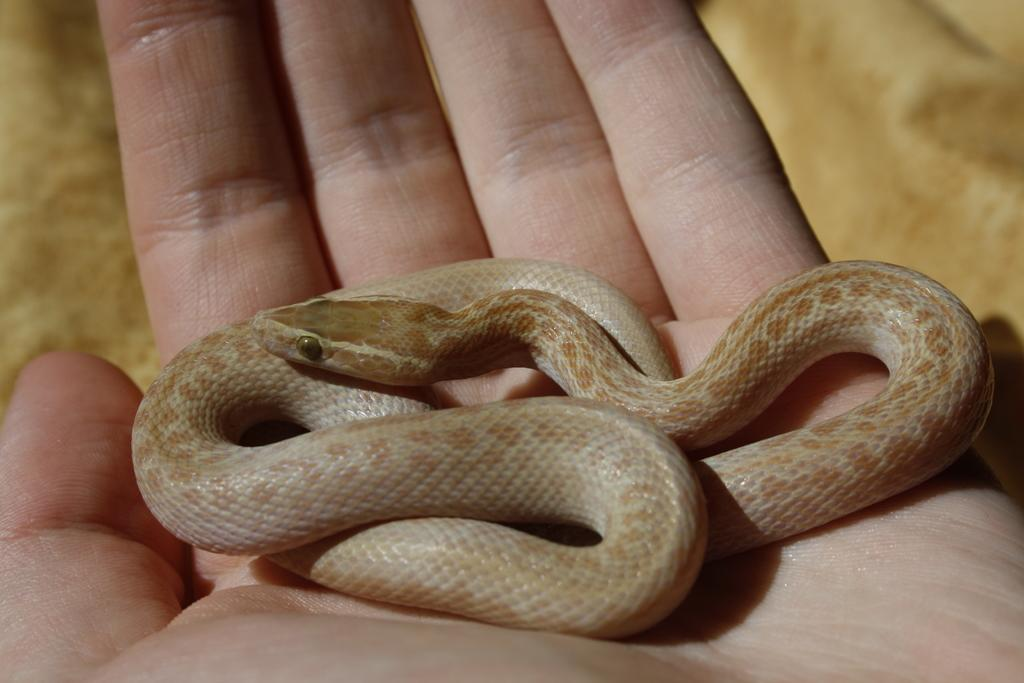What type of animal is in the image? There is a brown and cream color snake in the image. Where is the snake located in the image? The snake is on a person's hand. What color is the background of the image? The background of the image is brown in color. How many cows can be seen in the image? There are no cows present in the image; it features a brown and cream color snake on a person's hand. What type of dust is visible in the image? There is no dust visible in the image; the background color is brown. 